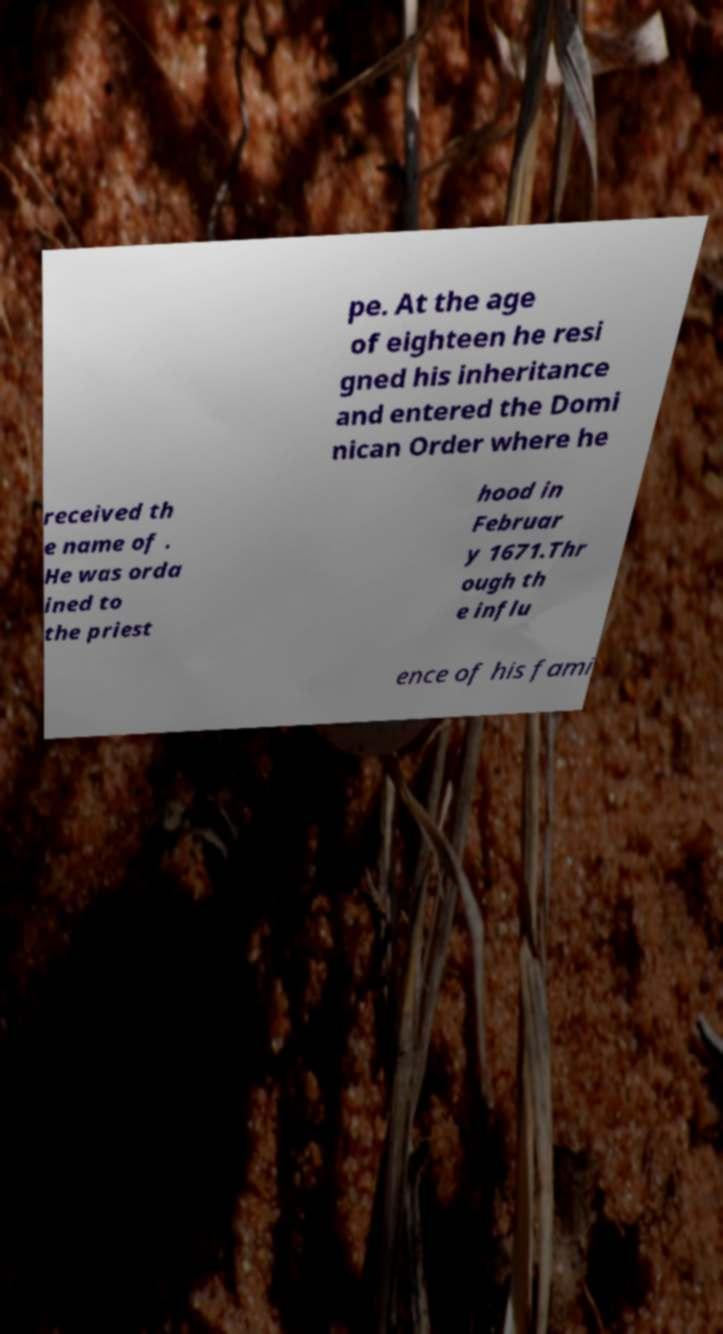Please read and relay the text visible in this image. What does it say? pe. At the age of eighteen he resi gned his inheritance and entered the Domi nican Order where he received th e name of . He was orda ined to the priest hood in Februar y 1671.Thr ough th e influ ence of his fami 